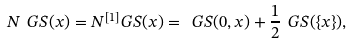<formula> <loc_0><loc_0><loc_500><loc_500>N _ { \ } G S ( x ) = N ^ { [ 1 ] } _ { \ } G S ( x ) = \ G S ( 0 , x ) + \frac { 1 } { 2 } \ G S ( \{ x \} ) ,</formula> 